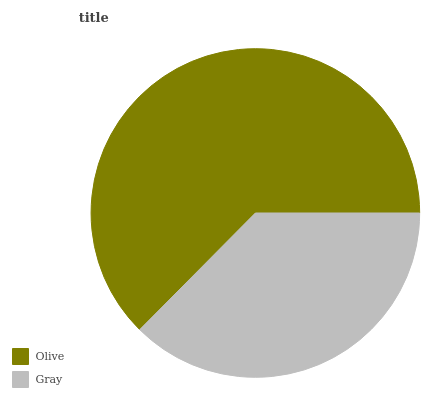Is Gray the minimum?
Answer yes or no. Yes. Is Olive the maximum?
Answer yes or no. Yes. Is Gray the maximum?
Answer yes or no. No. Is Olive greater than Gray?
Answer yes or no. Yes. Is Gray less than Olive?
Answer yes or no. Yes. Is Gray greater than Olive?
Answer yes or no. No. Is Olive less than Gray?
Answer yes or no. No. Is Olive the high median?
Answer yes or no. Yes. Is Gray the low median?
Answer yes or no. Yes. Is Gray the high median?
Answer yes or no. No. Is Olive the low median?
Answer yes or no. No. 